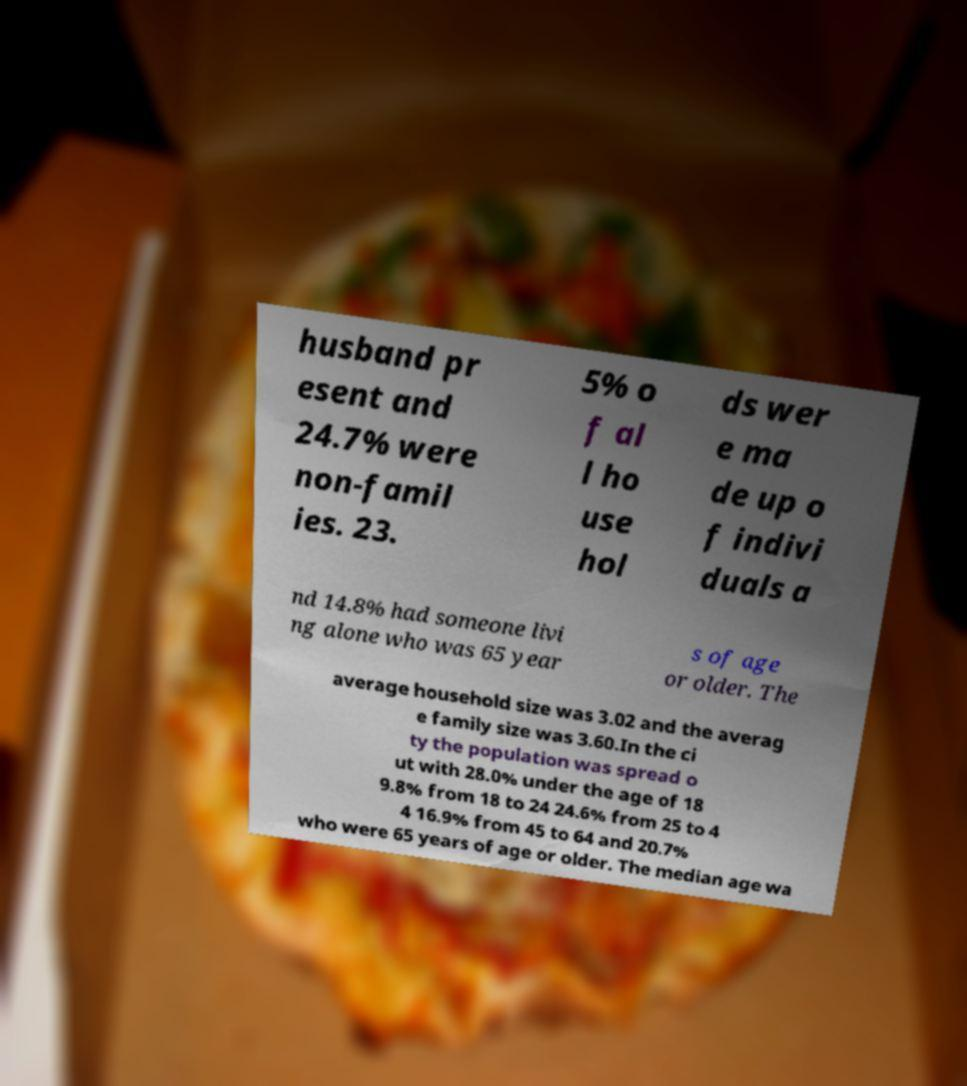What messages or text are displayed in this image? I need them in a readable, typed format. husband pr esent and 24.7% were non-famil ies. 23. 5% o f al l ho use hol ds wer e ma de up o f indivi duals a nd 14.8% had someone livi ng alone who was 65 year s of age or older. The average household size was 3.02 and the averag e family size was 3.60.In the ci ty the population was spread o ut with 28.0% under the age of 18 9.8% from 18 to 24 24.6% from 25 to 4 4 16.9% from 45 to 64 and 20.7% who were 65 years of age or older. The median age wa 